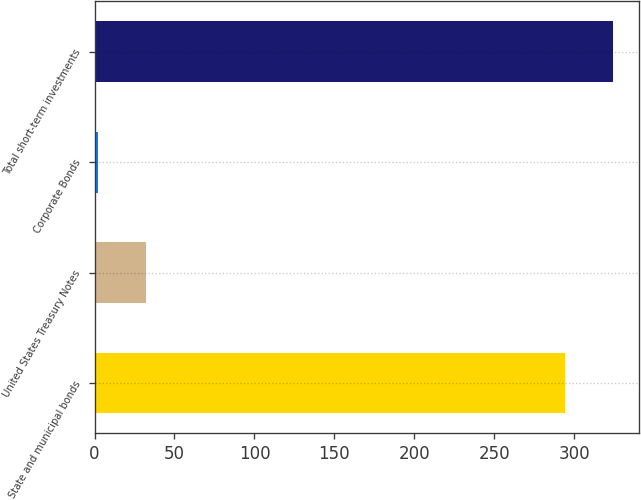<chart> <loc_0><loc_0><loc_500><loc_500><bar_chart><fcel>State and municipal bonds<fcel>United States Treasury Notes<fcel>Corporate Bonds<fcel>Total short-term investments<nl><fcel>294<fcel>32.3<fcel>2<fcel>324.3<nl></chart> 